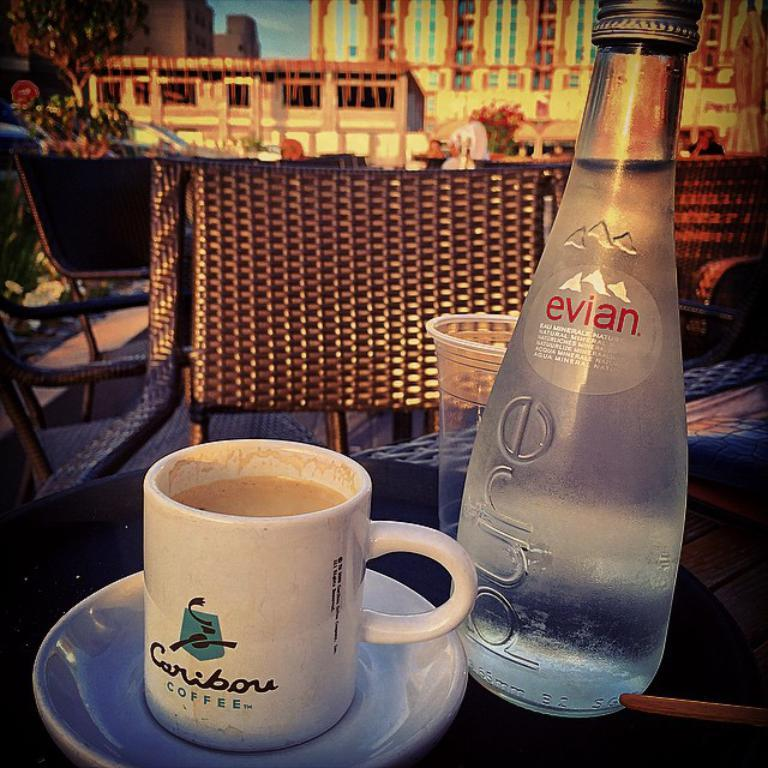What type of beverage container is visible in the image? There is a coffee cup in the image. What other type of beverage container is visible in the image? There is a water bottle in the image. Where are the coffee cup and water bottle located? Both the coffee cup and water bottle are on a table. What can be seen in the background of the image? There is a chair, a plant, a building, and the sky visible in the background of the image. What nation is represented by the flag on the tray in the image? There is no flag or tray present in the image. 